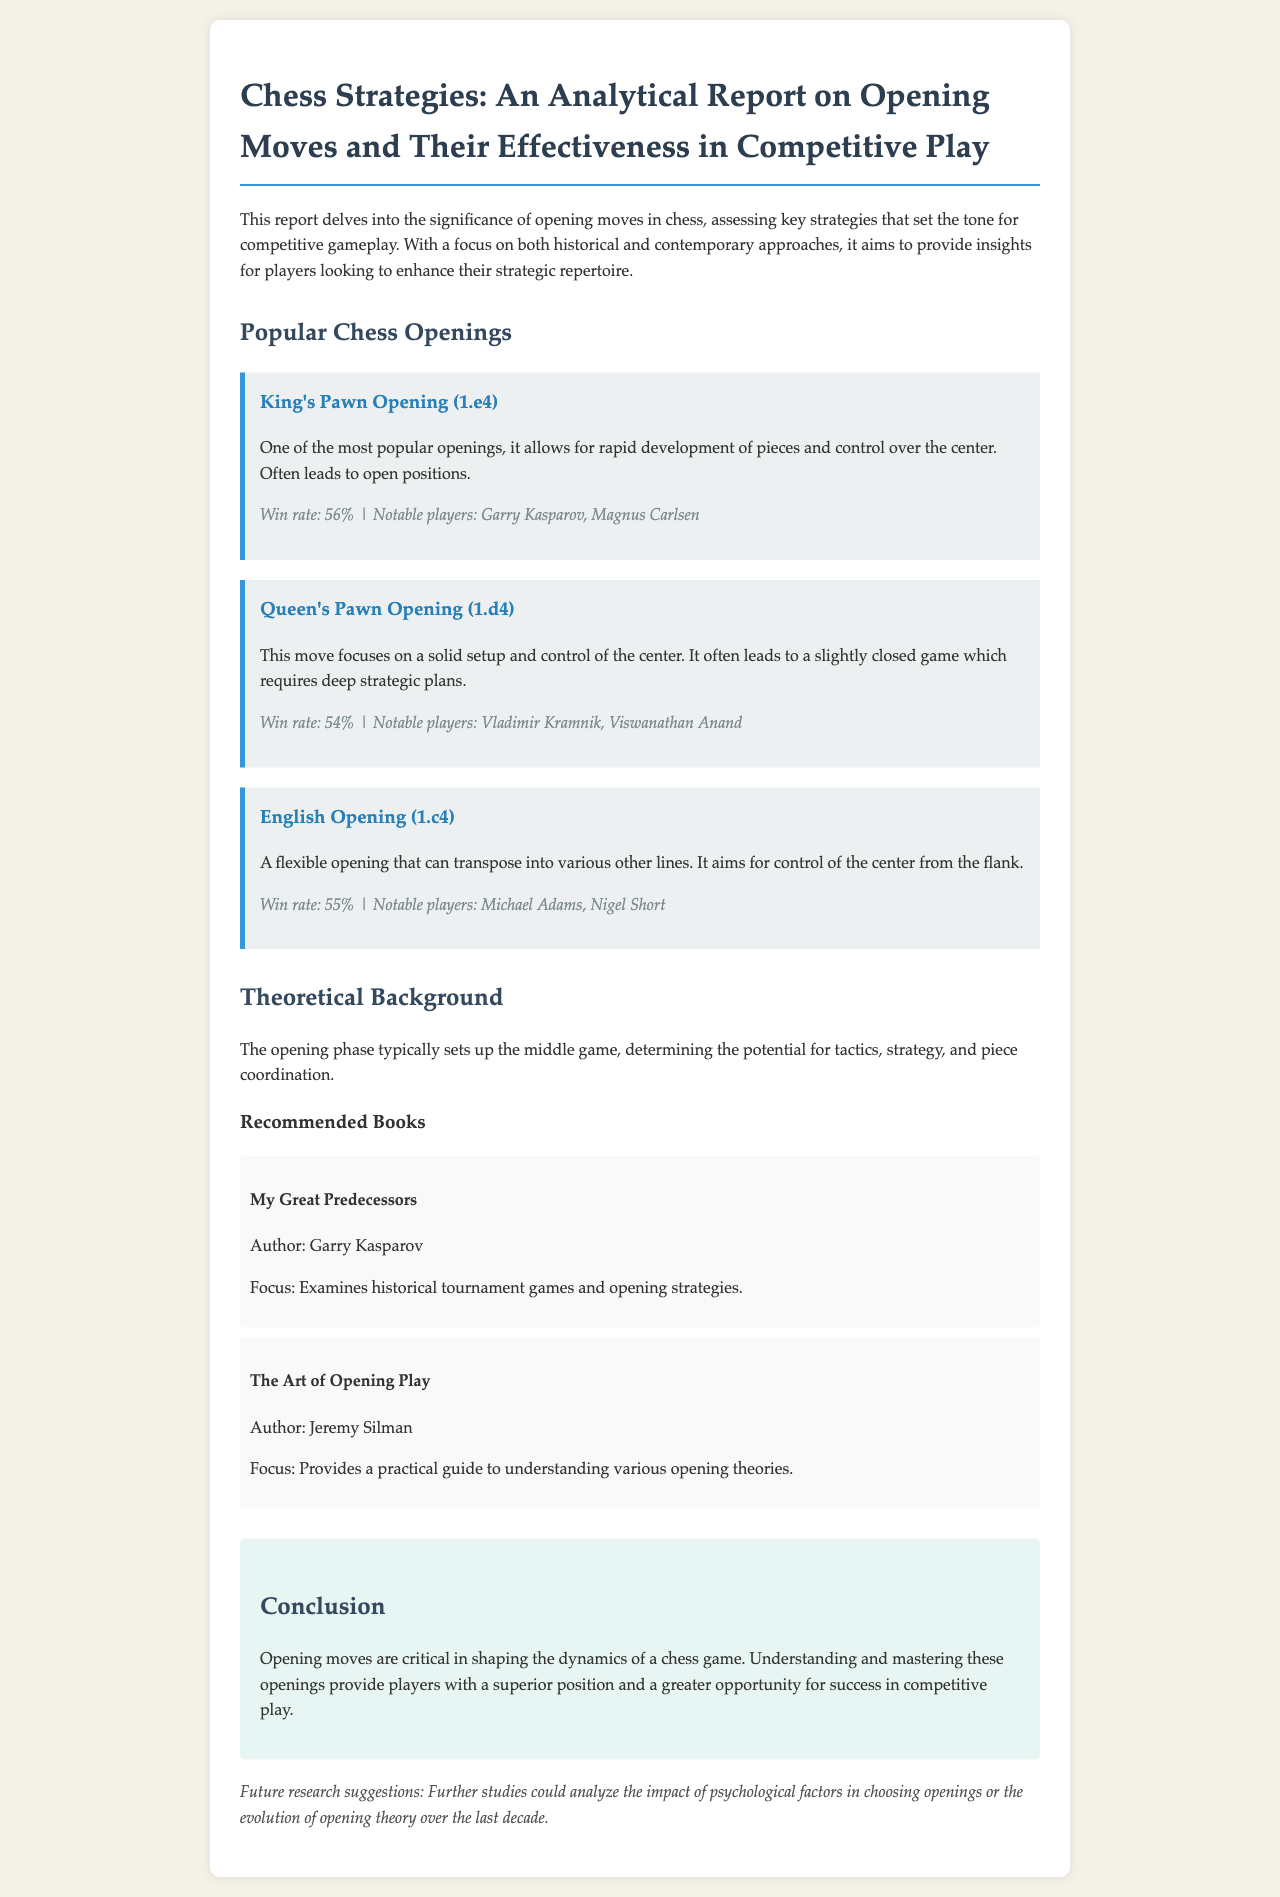What is the title of the report? The title is presented in the header of the document and summarizes the main focus of the content.
Answer: Chess Strategies: An Analytical Report on Opening Moves and Their Effectiveness in Competitive Play What is the win rate of the King's Pawn Opening? The win rate is specified in the description of the opening moves section under the King's Pawn Opening.
Answer: 56% Who are the notable players associated with the Queen's Pawn Opening? This information is included in the effectiveness statement for the Queen's Pawn Opening.
Answer: Vladimir Kramnik, Viswanathan Anand What does the English Opening aim to control? The aim of the English Opening is outlined in its description and helps explain its strategic intentions.
Answer: Center Which book is authored by Garry Kasparov? The book list includes the author names and their respective works, making it clear.
Answer: My Great Predecessors In what phase do opening moves primarily set up the game? The report discusses the relationship between opening moves and subsequent gameplay phases.
Answer: Middle game What is the suggested focus for future research? The document specifies areas for further exploration relating to chess openings.
Answer: Psychological factors What color is the background of the conclusion section? The document notes the formatting and color scheme for different sections, including this one.
Answer: Light blue 